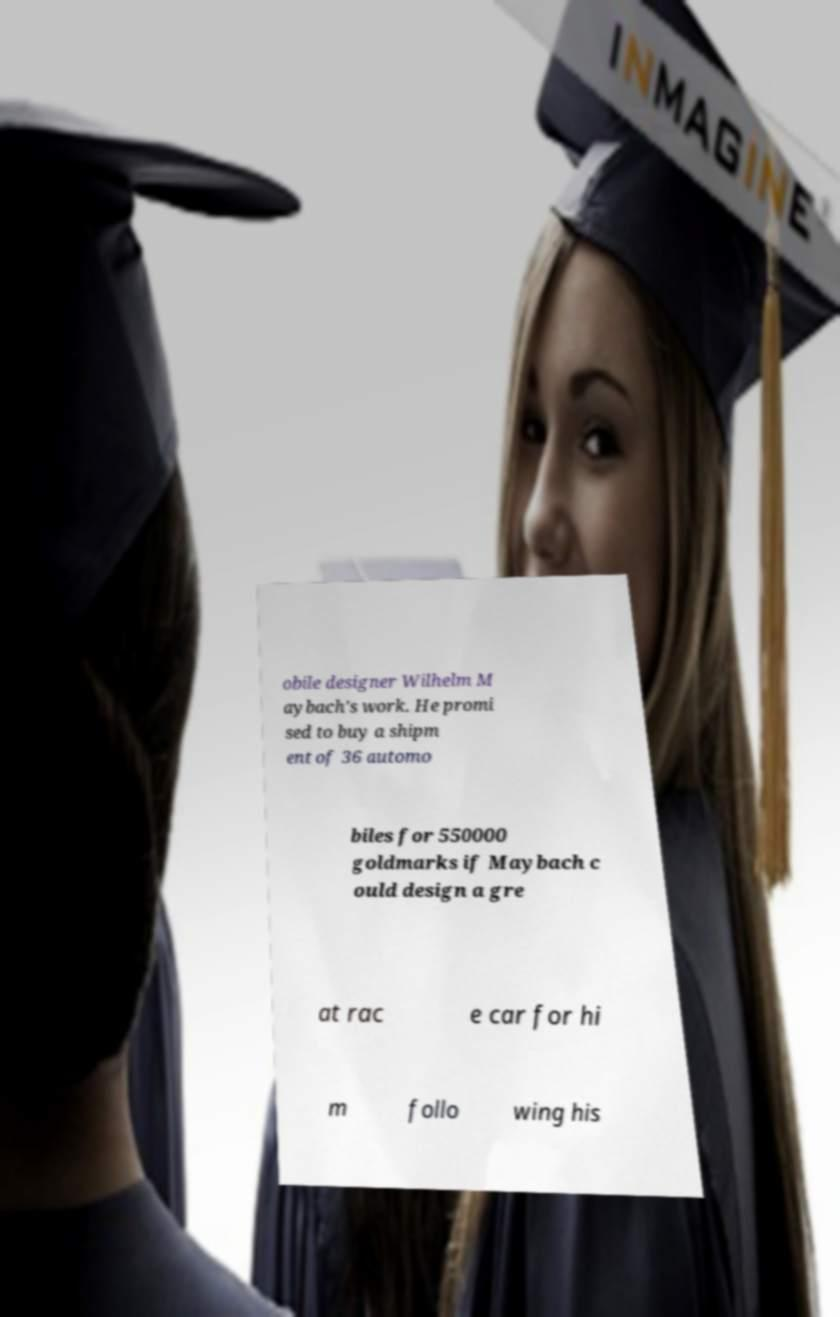There's text embedded in this image that I need extracted. Can you transcribe it verbatim? obile designer Wilhelm M aybach's work. He promi sed to buy a shipm ent of 36 automo biles for 550000 goldmarks if Maybach c ould design a gre at rac e car for hi m follo wing his 